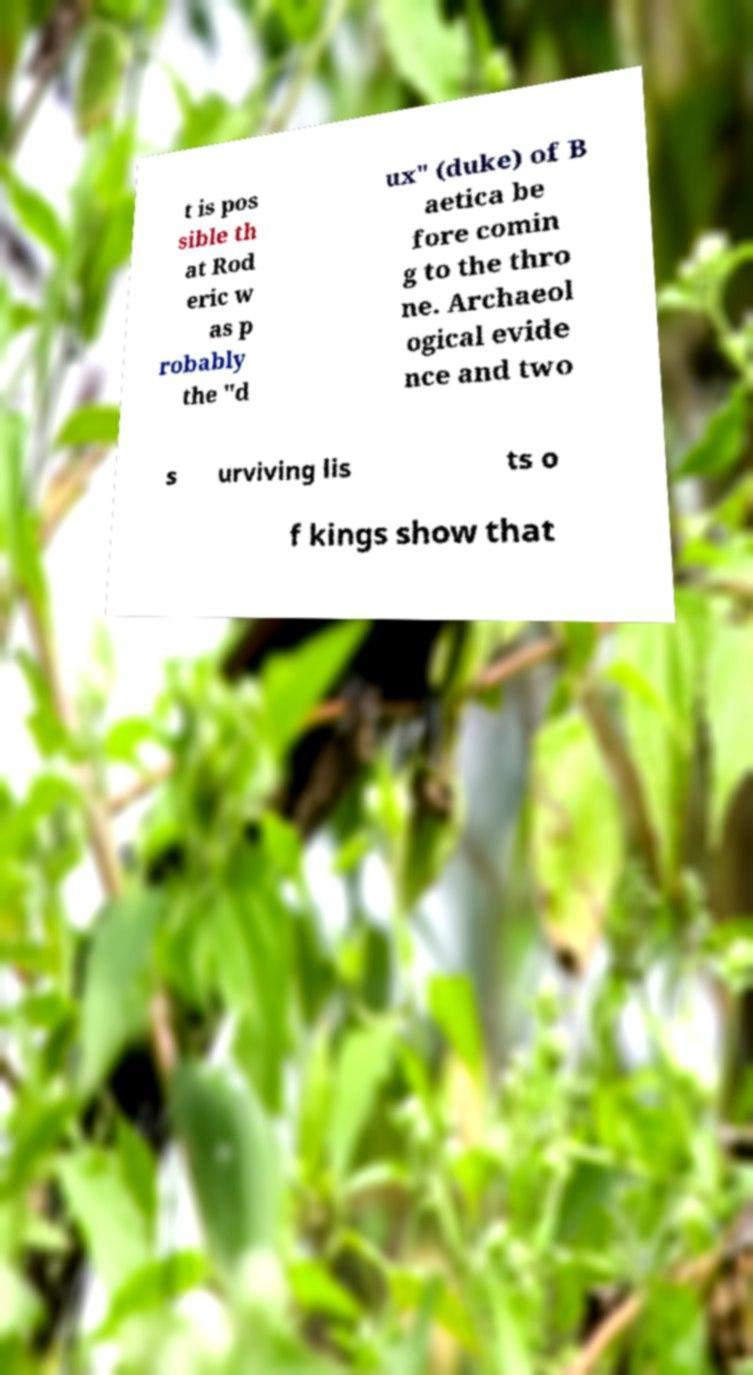Can you accurately transcribe the text from the provided image for me? t is pos sible th at Rod eric w as p robably the "d ux" (duke) of B aetica be fore comin g to the thro ne. Archaeol ogical evide nce and two s urviving lis ts o f kings show that 